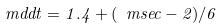Convert formula to latex. <formula><loc_0><loc_0><loc_500><loc_500>\ m d d t = 1 . 4 + ( \ m s e c - 2 ) / 6</formula> 